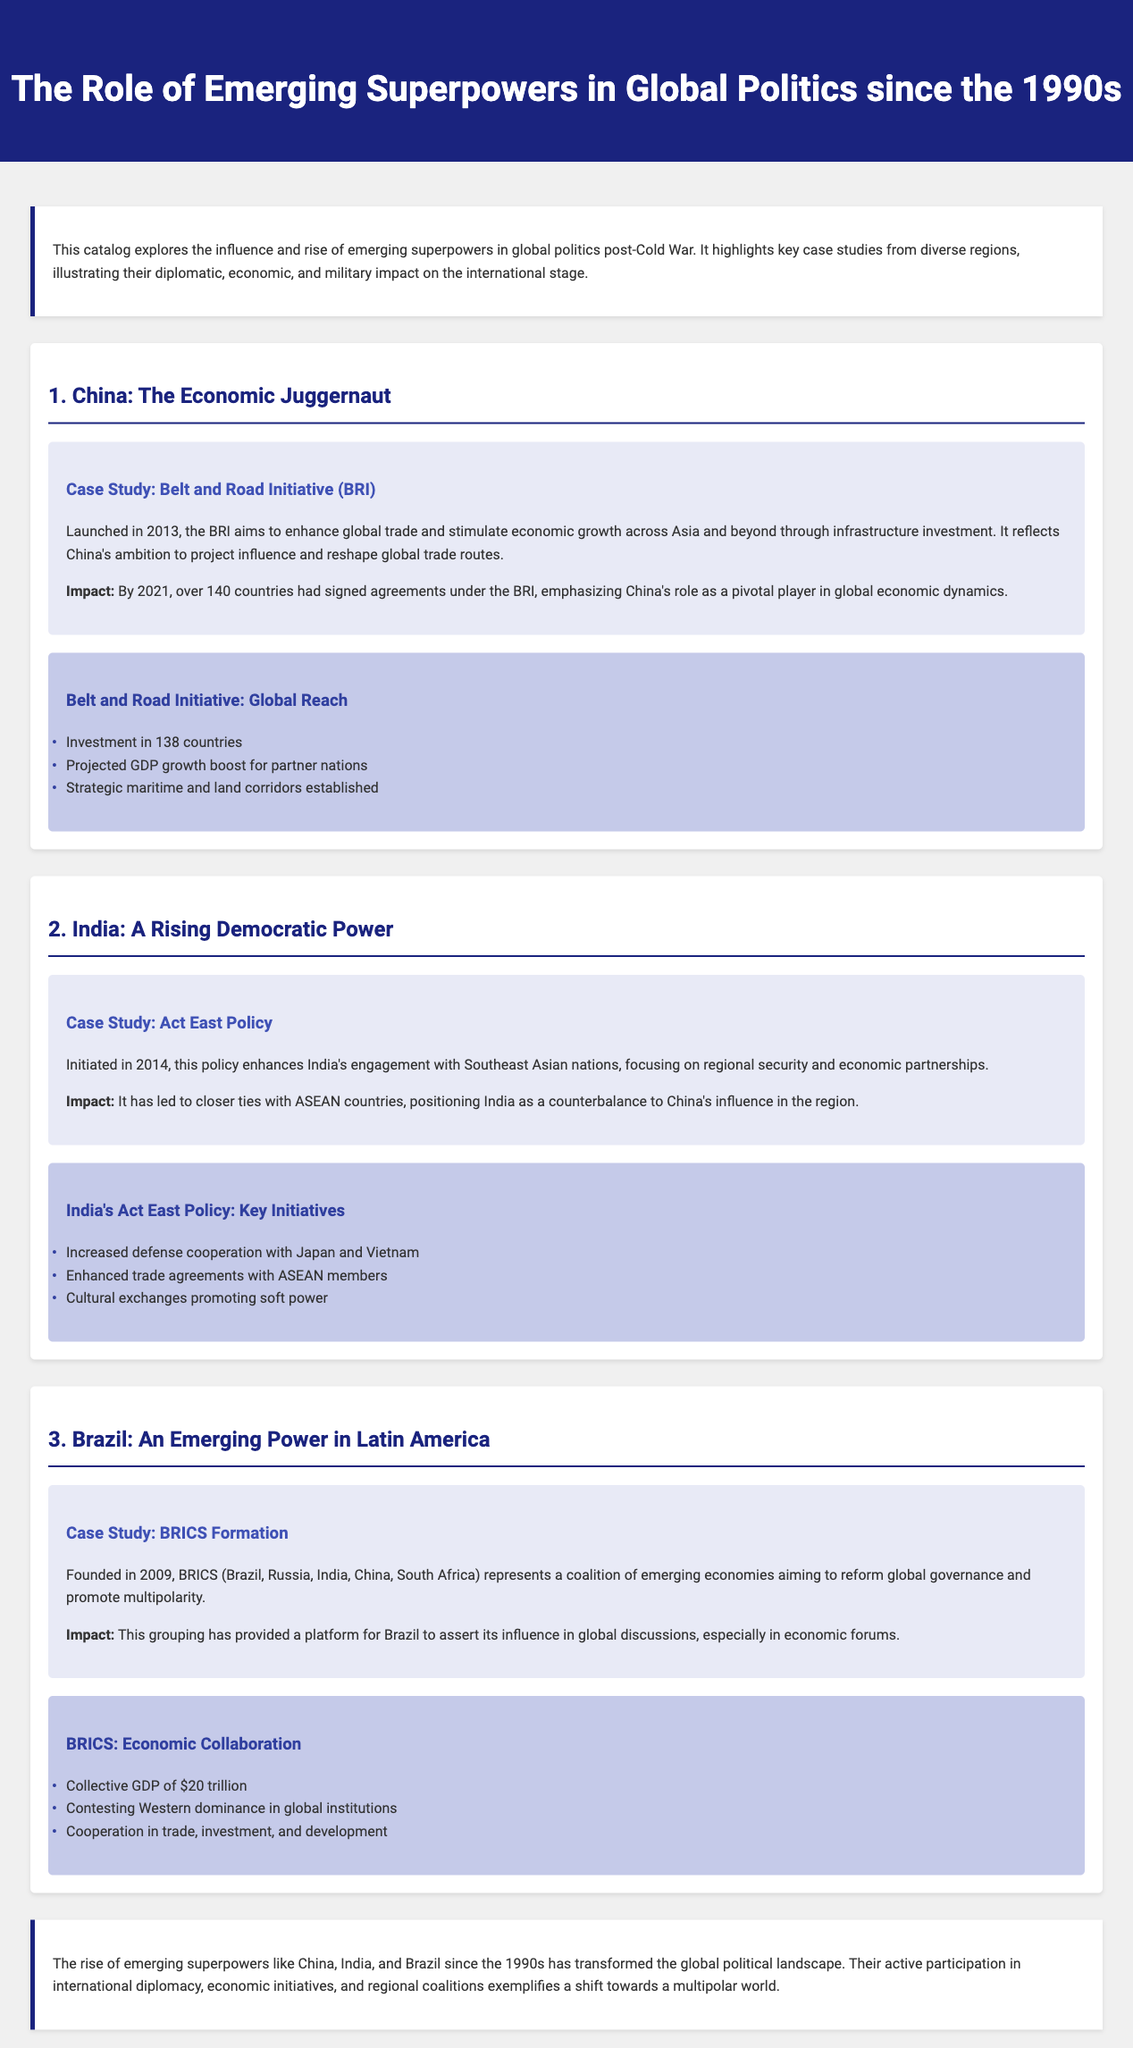What is the title of the catalog? The title is prominently displayed at the top of the document, indicating the main focus of the content.
Answer: The Role of Emerging Superpowers in Global Politics since the 1990s Which policy was initiated by India in 2014? The document explicitly mentions this policy in the context of India's diplomatic initiatives in Southeast Asia.
Answer: Act East Policy How many countries signed agreements under the Belt and Road Initiative by 2021? The document states the number of countries involved in the BRI, emphasizing China's global influence.
Answer: Over 140 countries What coalition was formed in 2009 that includes Brazil? The document provides the name of this coalition, highlighting Brazil's role in a group of emerging economies.
Answer: BRICS What is the collective GDP of BRICS? The document provides a specific figure representing the combined economic strength of the BRICS nations.
Answer: $20 trillion What strategy does the Act East Policy focus on enhancing? The document outlines the main focus of the Act East Policy regarding regional relationships.
Answer: Regional security and economic partnerships Which initiative reflects China's ambition to reshape global trade routes? The document specifically mentions this initiative in the context of China's economic strategy.
Answer: Belt and Road Initiative What color is used for the headings in the infographic sections? The document describes the color scheme of the infographic headings, contributing to the visual design.
Answer: #303f9f 